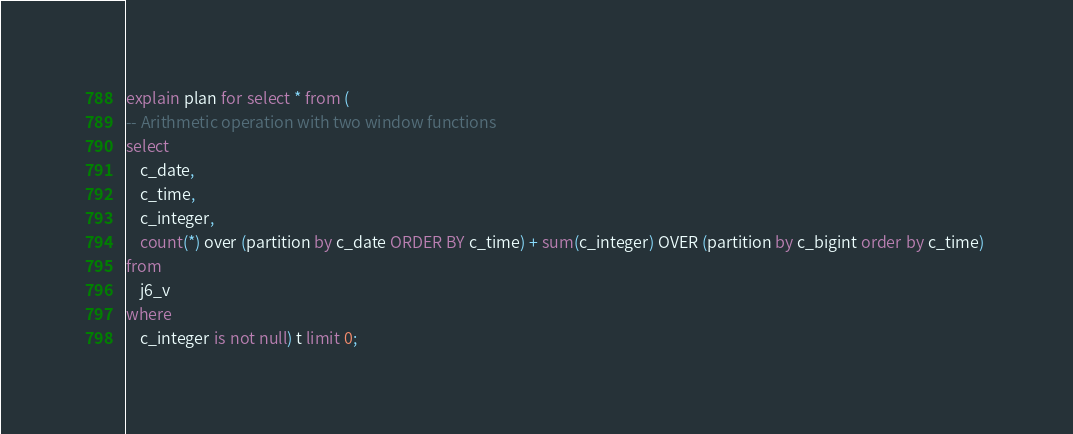<code> <loc_0><loc_0><loc_500><loc_500><_SQL_>explain plan for select * from (
-- Arithmetic operation with two window functions
select 
	c_date,
	c_time,
	c_integer,
	count(*) over (partition by c_date ORDER BY c_time) + sum(c_integer) OVER (partition by c_bigint order by c_time) 
from 
	j6_v 
where 
	c_integer is not null) t limit 0;
</code> 